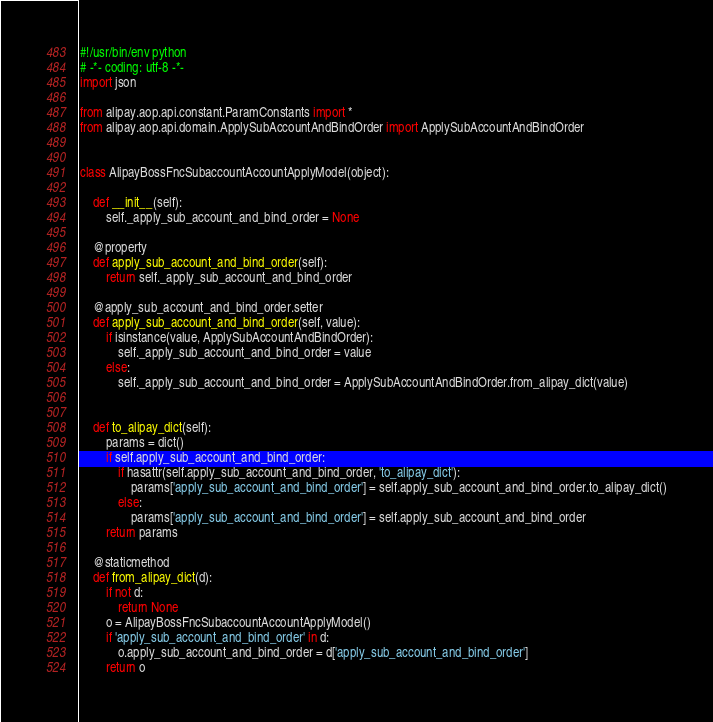Convert code to text. <code><loc_0><loc_0><loc_500><loc_500><_Python_>#!/usr/bin/env python
# -*- coding: utf-8 -*-
import json

from alipay.aop.api.constant.ParamConstants import *
from alipay.aop.api.domain.ApplySubAccountAndBindOrder import ApplySubAccountAndBindOrder


class AlipayBossFncSubaccountAccountApplyModel(object):

    def __init__(self):
        self._apply_sub_account_and_bind_order = None

    @property
    def apply_sub_account_and_bind_order(self):
        return self._apply_sub_account_and_bind_order

    @apply_sub_account_and_bind_order.setter
    def apply_sub_account_and_bind_order(self, value):
        if isinstance(value, ApplySubAccountAndBindOrder):
            self._apply_sub_account_and_bind_order = value
        else:
            self._apply_sub_account_and_bind_order = ApplySubAccountAndBindOrder.from_alipay_dict(value)


    def to_alipay_dict(self):
        params = dict()
        if self.apply_sub_account_and_bind_order:
            if hasattr(self.apply_sub_account_and_bind_order, 'to_alipay_dict'):
                params['apply_sub_account_and_bind_order'] = self.apply_sub_account_and_bind_order.to_alipay_dict()
            else:
                params['apply_sub_account_and_bind_order'] = self.apply_sub_account_and_bind_order
        return params

    @staticmethod
    def from_alipay_dict(d):
        if not d:
            return None
        o = AlipayBossFncSubaccountAccountApplyModel()
        if 'apply_sub_account_and_bind_order' in d:
            o.apply_sub_account_and_bind_order = d['apply_sub_account_and_bind_order']
        return o


</code> 